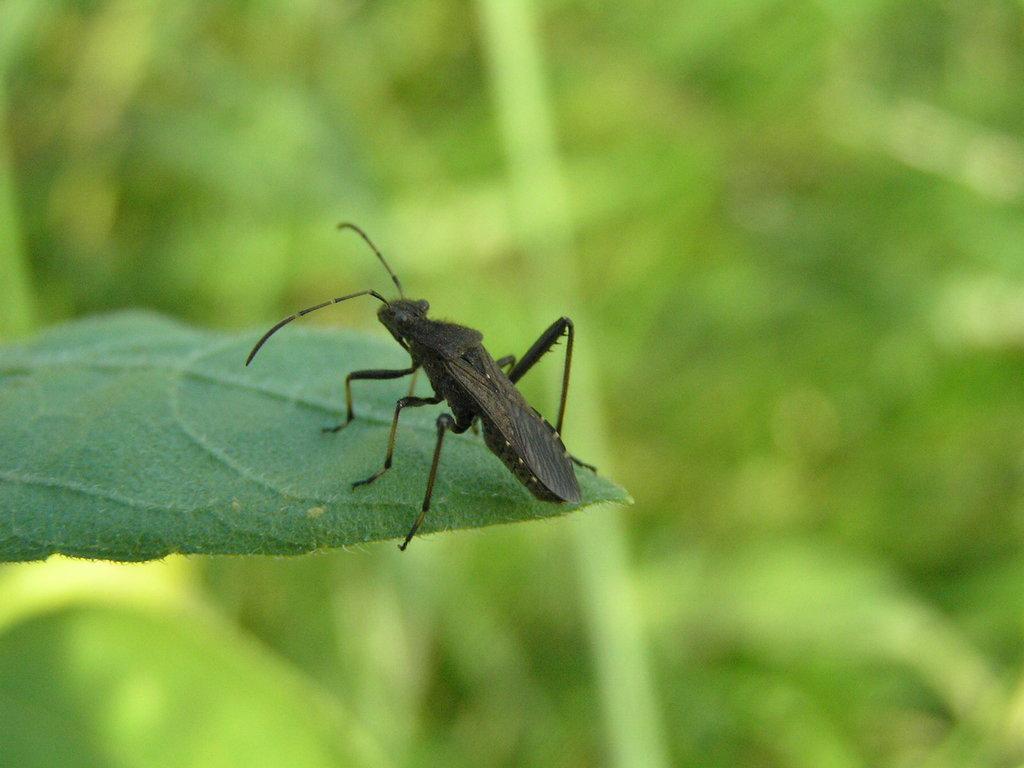In one or two sentences, can you explain what this image depicts? In this picture we can see an insect on the leaf. 